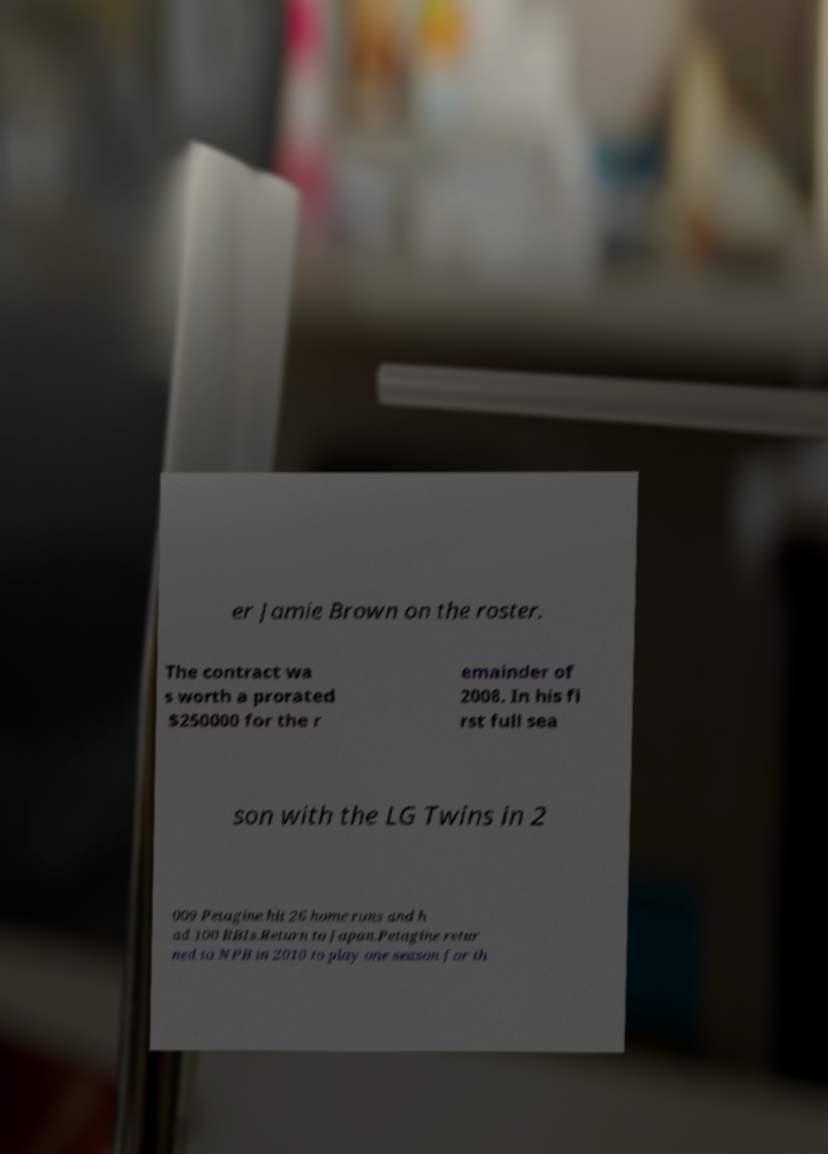Could you assist in decoding the text presented in this image and type it out clearly? er Jamie Brown on the roster. The contract wa s worth a prorated $250000 for the r emainder of 2008. In his fi rst full sea son with the LG Twins in 2 009 Petagine hit 26 home runs and h ad 100 RBIs.Return to Japan.Petagine retur ned to NPB in 2010 to play one season for th 